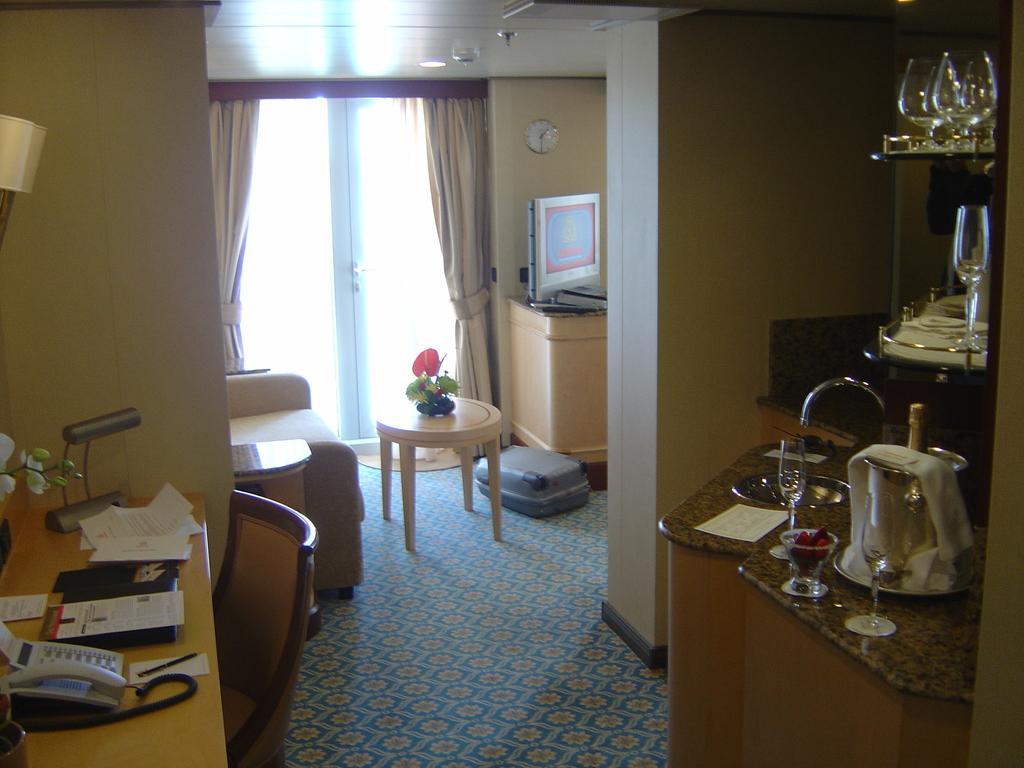In one or two sentences, can you explain what this image depicts? In this picture we can see some glasses here, on the left side there is a table and a chair, we can see a telephone and some papers on the table, in the background there is a television, we can see curtains here, we can see a plant where, there is a couch here. 